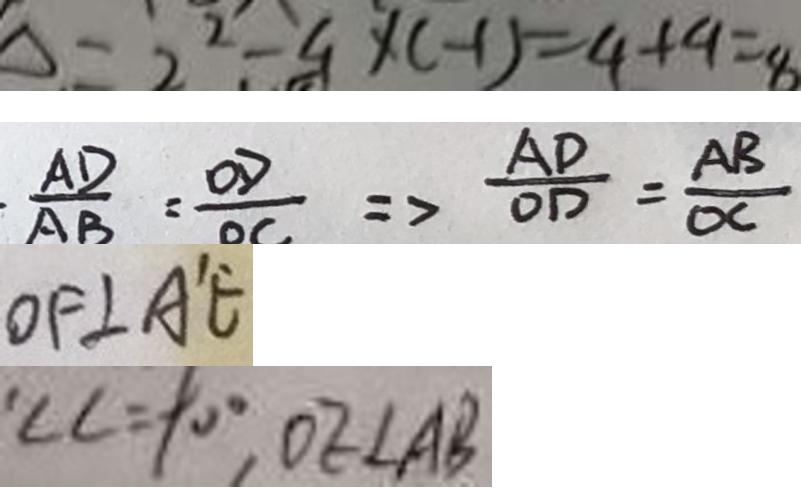<formula> <loc_0><loc_0><loc_500><loc_500>\Delta = 2 ^ { 2 } - 4 \times ( - 1 ) = 4 + 4 = 8 
 \frac { A D } { A B } = \frac { O D } { O C } \Rightarrow \frac { A D } { O D } = \frac { A B } { O C } 
 O F \bot A ^ { \prime } E 
 \angle C = 9 0 ^ { \circ } , O E \bot A B</formula> 